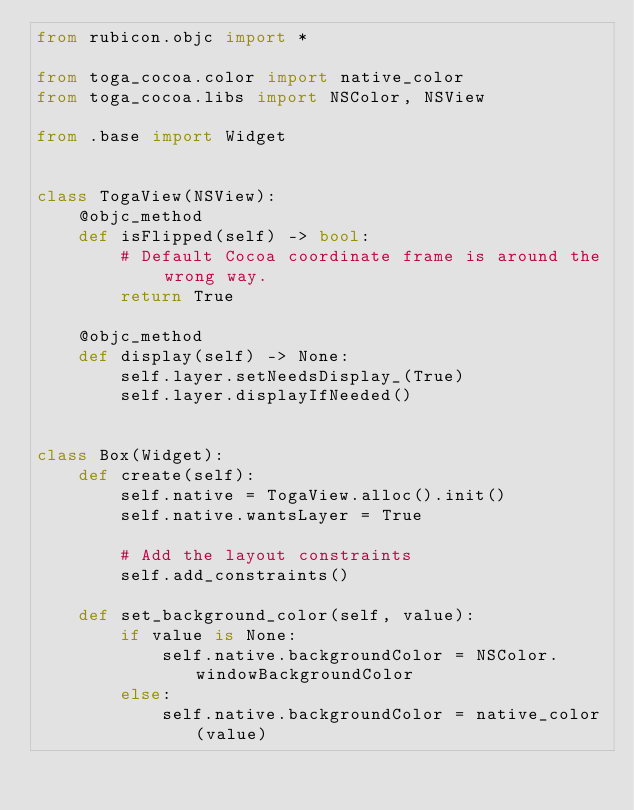Convert code to text. <code><loc_0><loc_0><loc_500><loc_500><_Python_>from rubicon.objc import *

from toga_cocoa.color import native_color
from toga_cocoa.libs import NSColor, NSView

from .base import Widget


class TogaView(NSView):
    @objc_method
    def isFlipped(self) -> bool:
        # Default Cocoa coordinate frame is around the wrong way.
        return True

    @objc_method
    def display(self) -> None:
        self.layer.setNeedsDisplay_(True)
        self.layer.displayIfNeeded()


class Box(Widget):
    def create(self):
        self.native = TogaView.alloc().init()
        self.native.wantsLayer = True

        # Add the layout constraints
        self.add_constraints()

    def set_background_color(self, value):
        if value is None:
            self.native.backgroundColor = NSColor.windowBackgroundColor
        else:
            self.native.backgroundColor = native_color(value)
</code> 